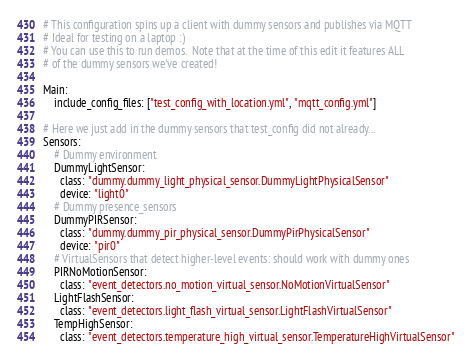Convert code to text. <code><loc_0><loc_0><loc_500><loc_500><_YAML_># This configuration spins up a client with dummy sensors and publishes via MQTT
# Ideal for testing on a laptop :)
# You can use this to run demos.  Note that at the time of this edit it features ALL
# of the dummy sensors we've created!

Main:
    include_config_files: ["test_config_with_location.yml", "mqtt_config.yml"]

# Here we just add in the dummy sensors that test_config did not already...
Sensors:
    # Dummy environment
    DummyLightSensor:
      class: "dummy.dummy_light_physical_sensor.DummyLightPhysicalSensor"
      device: "light0"
    # Dummy presence_sensors
    DummyPIRSensor:
      class: "dummy.dummy_pir_physical_sensor.DummyPirPhysicalSensor"
      device: "pir0"
    # VirtualSensors that detect higher-level events: should work with dummy ones
    PIRNoMotionSensor:
      class: "event_detectors.no_motion_virtual_sensor.NoMotionVirtualSensor"
    LightFlashSensor:
      class: "event_detectors.light_flash_virtual_sensor.LightFlashVirtualSensor"
    TempHighSensor:
      class: "event_detectors.temperature_high_virtual_sensor.TemperatureHighVirtualSensor"</code> 